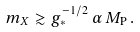Convert formula to latex. <formula><loc_0><loc_0><loc_500><loc_500>m _ { X } \gtrsim g _ { * } ^ { - 1 / 2 } \, \alpha \, M _ { \mathrm P } \, .</formula> 